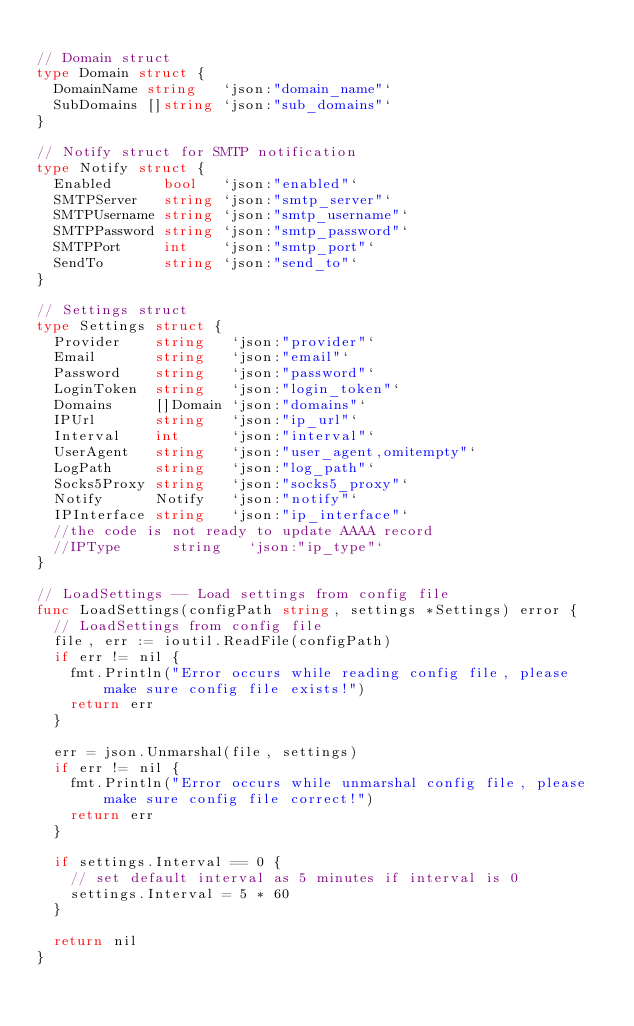Convert code to text. <code><loc_0><loc_0><loc_500><loc_500><_Go_>
// Domain struct
type Domain struct {
	DomainName string   `json:"domain_name"`
	SubDomains []string `json:"sub_domains"`
}

// Notify struct for SMTP notification
type Notify struct {
	Enabled      bool   `json:"enabled"`
	SMTPServer   string `json:"smtp_server"`
	SMTPUsername string `json:"smtp_username"`
	SMTPPassword string `json:"smtp_password"`
	SMTPPort     int    `json:"smtp_port"`
	SendTo       string `json:"send_to"`
}

// Settings struct
type Settings struct {
	Provider    string   `json:"provider"`
	Email       string   `json:"email"`
	Password    string   `json:"password"`
	LoginToken  string   `json:"login_token"`
	Domains     []Domain `json:"domains"`
	IPUrl       string   `json:"ip_url"`
	Interval    int      `json:"interval"`
	UserAgent   string   `json:"user_agent,omitempty"`
	LogPath     string   `json:"log_path"`
	Socks5Proxy string   `json:"socks5_proxy"`
	Notify      Notify   `json:"notify"`
	IPInterface string   `json:"ip_interface"`
	//the code is not ready to update AAAA record
	//IPType      string   `json:"ip_type"`
}

// LoadSettings -- Load settings from config file
func LoadSettings(configPath string, settings *Settings) error {
	// LoadSettings from config file
	file, err := ioutil.ReadFile(configPath)
	if err != nil {
		fmt.Println("Error occurs while reading config file, please make sure config file exists!")
		return err
	}

	err = json.Unmarshal(file, settings)
	if err != nil {
		fmt.Println("Error occurs while unmarshal config file, please make sure config file correct!")
		return err
	}

	if settings.Interval == 0 {
		// set default interval as 5 minutes if interval is 0
		settings.Interval = 5 * 60
	}

	return nil
}
</code> 